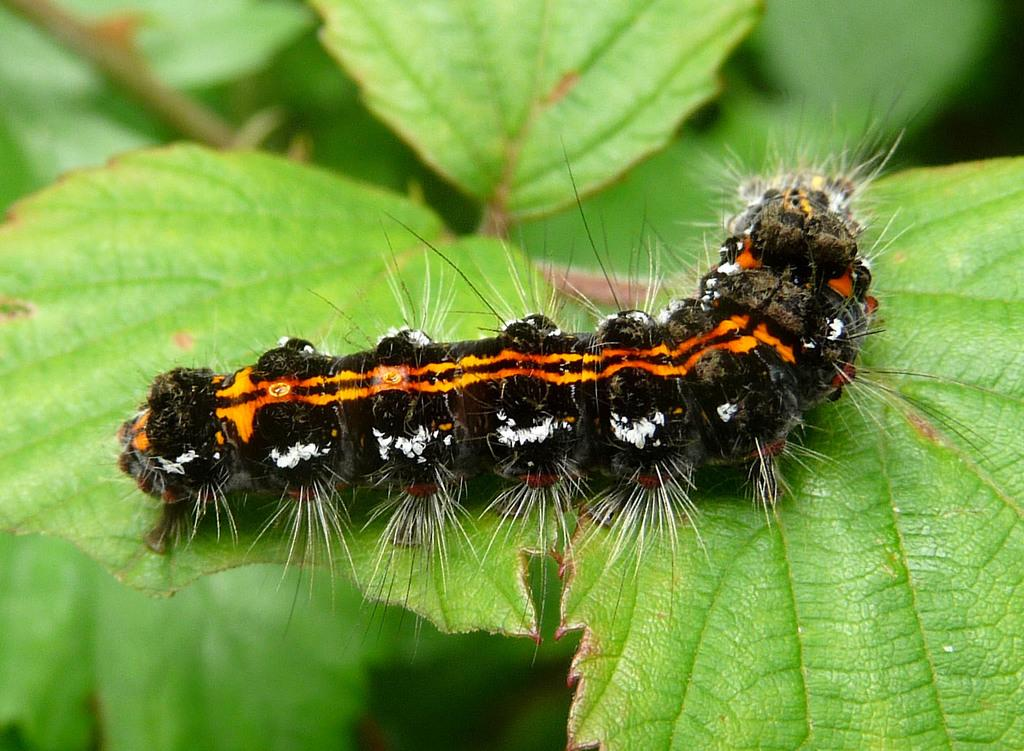What type of vegetation can be seen in the image? There are green leaves in the image. Is there any animal life present in the image? Yes, there is a caterpillar on one of the green leaves. What type of screw can be seen in the image? There is no screw present in the image; it features green leaves and a caterpillar. What type of wine is being served in the image? There is no wine present in the image; it features green leaves and a caterpillar. 